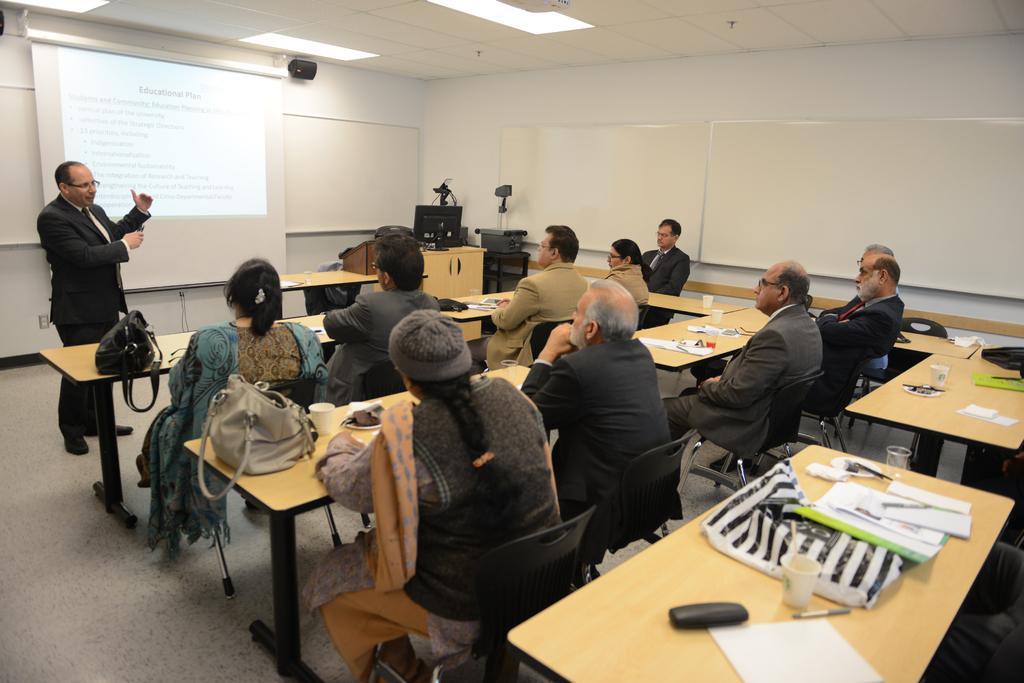In one or two sentences, can you explain what this image depicts? This image is clicked, in a classroom. There are many people in this image. To the left, the man wearing black suit, is standing and talking. In the background, there is a screen along with speaker on the wall. To the right, there are boards on the wall. There are many tables in this room. 